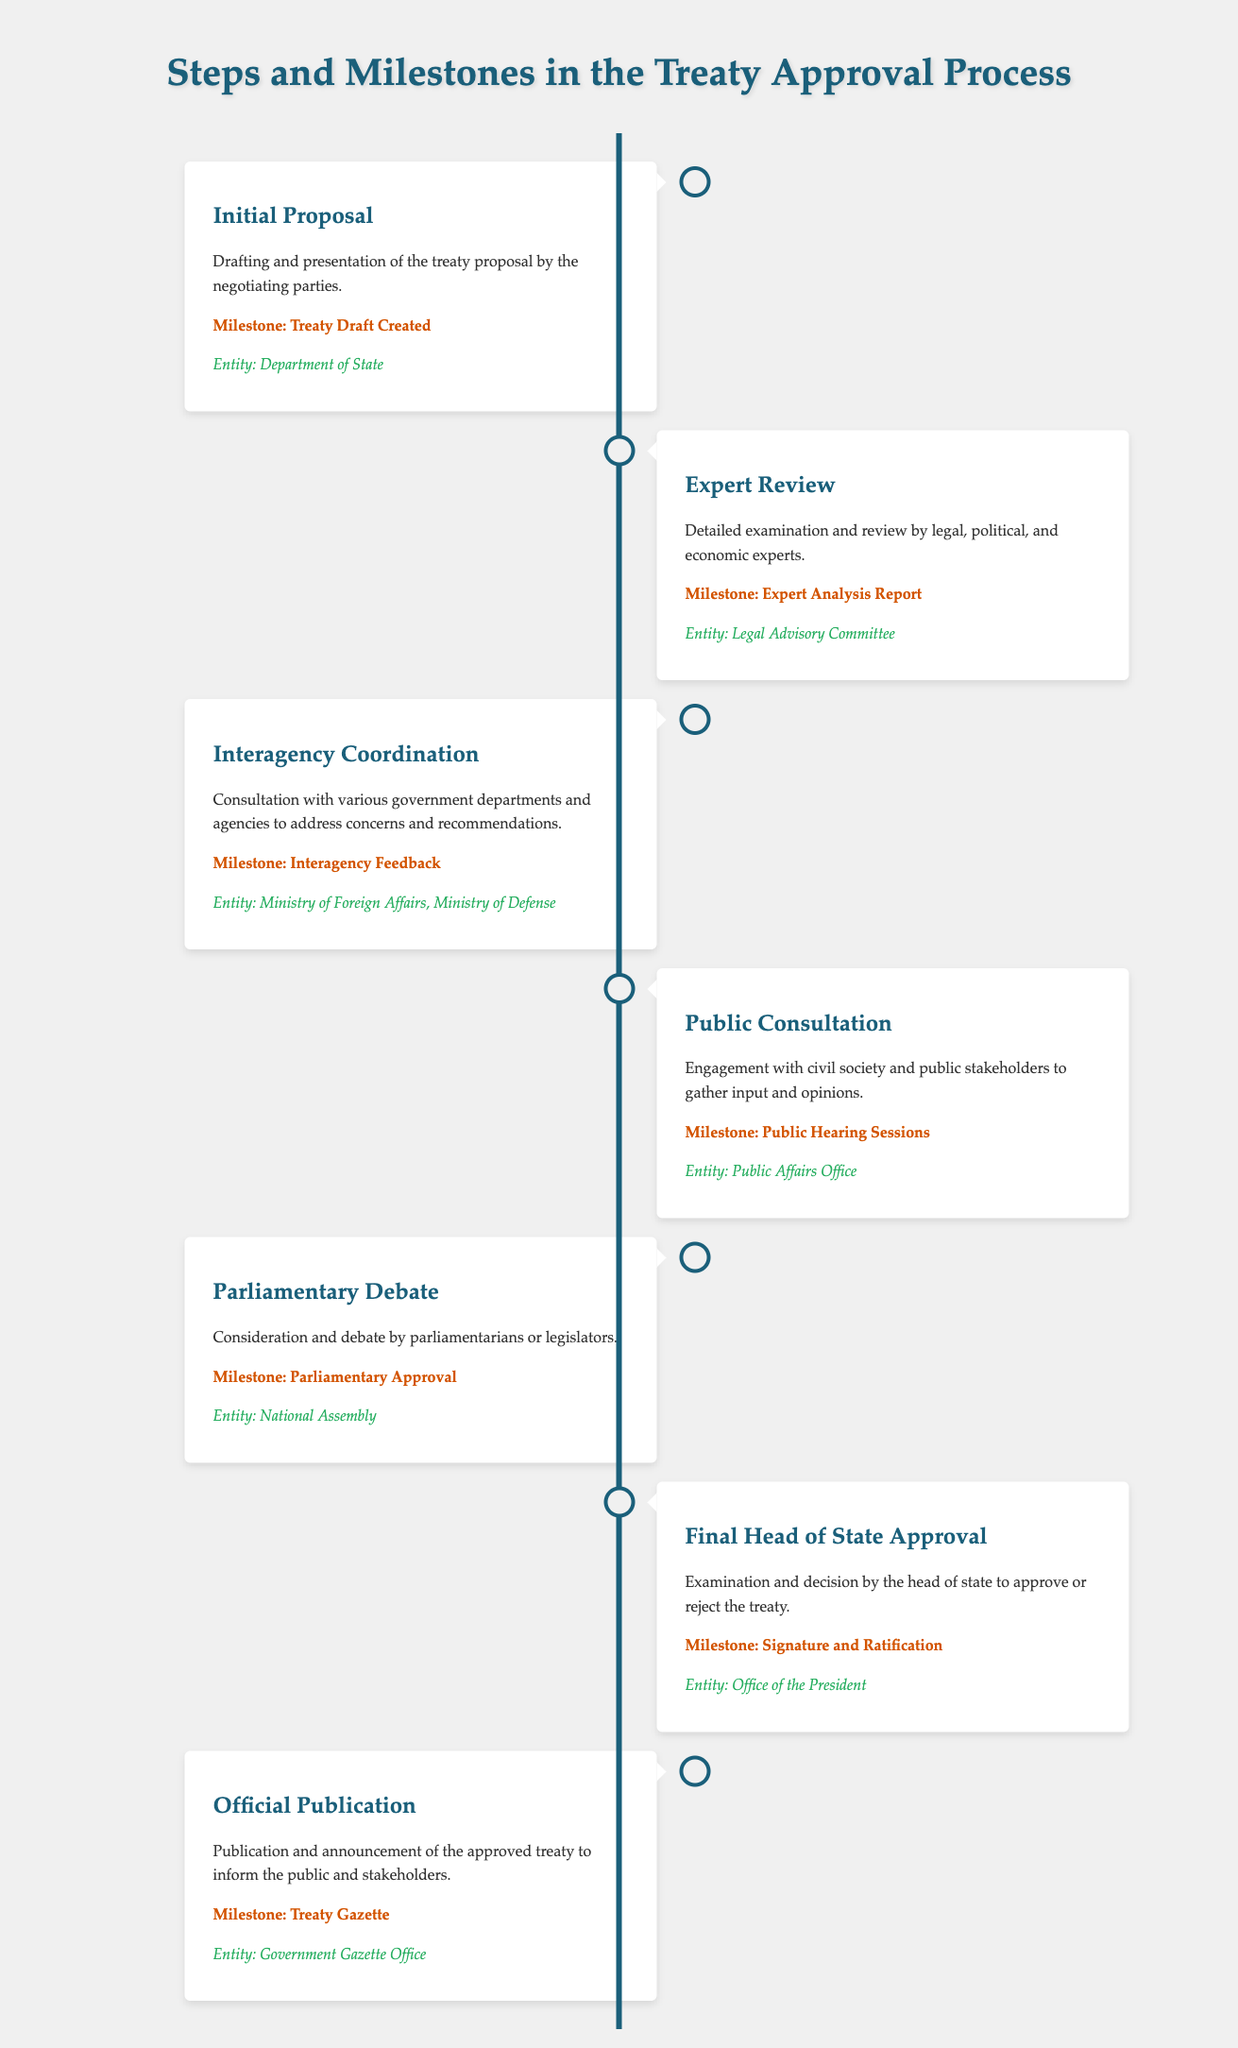What is the first step in the treaty approval process? The first step involves the drafting and presentation of the treaty proposal by the negotiating parties.
Answer: Initial Proposal Who conducts the expert review? The document states that the expert review is conducted by legal, political, and economic experts.
Answer: Legal Advisory Committee What is the milestone after the parliamentary debate? The document outlines that the milestone after the parliamentary debate is the signature and ratification.
Answer: Signature and Ratification Which office is responsible for the official publication of the treaty? The Government Gazette Office is mentioned as responsible for the official publication of the treaty.
Answer: Government Gazette Office What kind of input is sought during public consultation? The public consultation seeks input and opinions from civil society and public stakeholders.
Answer: Engagement with civil society What is the last milestone mentioned in the process? The last milestone referred to in the document is the publication and announcement of the approved treaty.
Answer: Treaty Gazette How many main steps are detailed in the document? The document lists a total of six main steps in the treaty approval process.
Answer: Six Which entity leads the initial proposal drafting? The Department of State is identified as the entity that drafts the initial proposal.
Answer: Department of State 